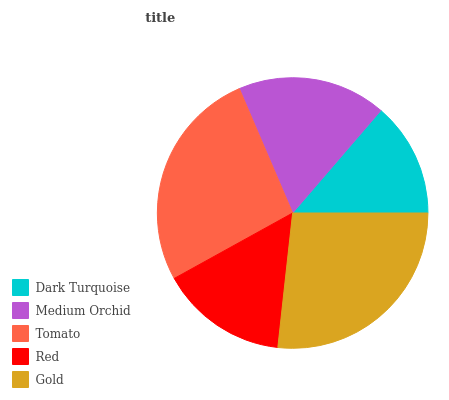Is Dark Turquoise the minimum?
Answer yes or no. Yes. Is Gold the maximum?
Answer yes or no. Yes. Is Medium Orchid the minimum?
Answer yes or no. No. Is Medium Orchid the maximum?
Answer yes or no. No. Is Medium Orchid greater than Dark Turquoise?
Answer yes or no. Yes. Is Dark Turquoise less than Medium Orchid?
Answer yes or no. Yes. Is Dark Turquoise greater than Medium Orchid?
Answer yes or no. No. Is Medium Orchid less than Dark Turquoise?
Answer yes or no. No. Is Medium Orchid the high median?
Answer yes or no. Yes. Is Medium Orchid the low median?
Answer yes or no. Yes. Is Red the high median?
Answer yes or no. No. Is Dark Turquoise the low median?
Answer yes or no. No. 